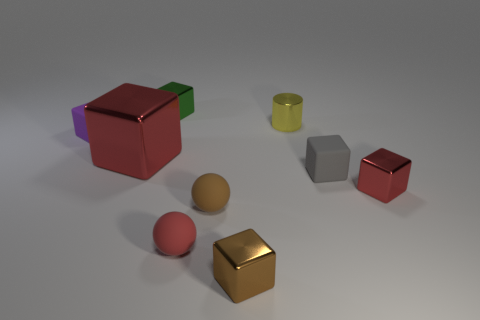What is the material of the brown thing in front of the brown sphere?
Offer a terse response. Metal. What number of objects are either small things that are to the right of the small red matte object or tiny brown shiny blocks?
Provide a short and direct response. 5. How many other objects are there of the same shape as the tiny yellow thing?
Your answer should be compact. 0. Do the object in front of the red matte ball and the brown rubber thing have the same shape?
Ensure brevity in your answer.  No. There is a small gray object; are there any red things left of it?
Keep it short and to the point. Yes. How many large objects are brown cubes or green metal cubes?
Ensure brevity in your answer.  0. Is the material of the tiny cylinder the same as the green cube?
Make the answer very short. Yes. What is the size of the shiny thing that is the same color as the big block?
Provide a succinct answer. Small. Are there any other cubes of the same color as the big shiny cube?
Make the answer very short. Yes. There is a red thing that is made of the same material as the small purple object; what is its size?
Provide a short and direct response. Small. 